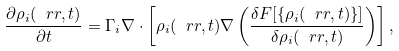<formula> <loc_0><loc_0><loc_500><loc_500>\frac { \partial \rho _ { i } ( \ r r , t ) } { \partial t } = \Gamma _ { i } \nabla \cdot \left [ \rho _ { i } ( \ r r , t ) \nabla \left ( \frac { \delta F [ \{ \rho _ { i } ( \ r r , t ) \} ] } { \delta \rho _ { i } ( \ r r , t ) } \right ) \right ] ,</formula> 